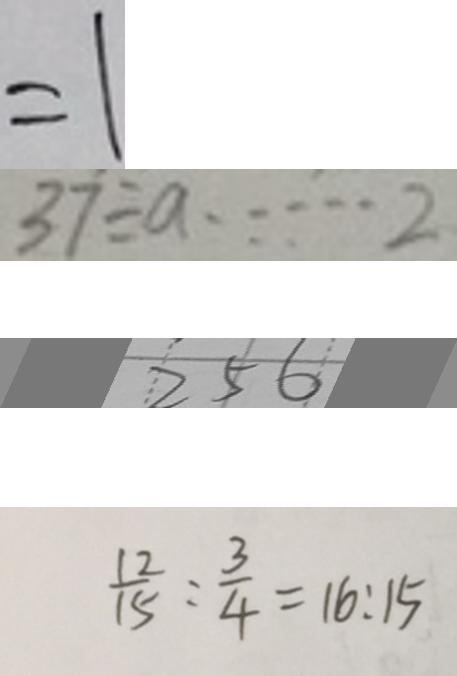<formula> <loc_0><loc_0><loc_500><loc_500>= 1 
 3 7 \div a \cdots 2 
 2 5 6 
 \frac { 1 2 } { 1 5 } : \frac { 3 } { 4 } = 1 6 : 1 5</formula> 